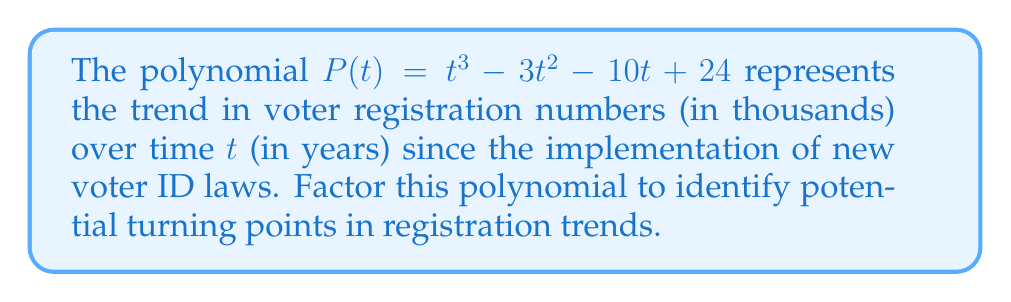Show me your answer to this math problem. To factor this polynomial, we'll follow these steps:

1) First, check if there are any rational roots using the rational root theorem. The possible rational roots are the factors of the constant term: ±1, ±2, ±3, ±4, ±6, ±8, ±12, ±24.

2) By testing these values, we find that t = 4 is a root. So (t - 4) is a factor.

3) Divide P(t) by (t - 4):

   $$(t^3 - 3t^2 - 10t + 24) ÷ (t - 4) = t^2 + t - 6$$

4) Now we need to factor the quadratic $t^2 + t - 6$. We can do this by finding two numbers that multiply to give -6 and add to give 1.

5) These numbers are 3 and -2. So we can factor $t^2 + t - 6$ as $(t + 3)(t - 2)$.

6) Combining all factors, we get:

   $$P(t) = (t - 4)(t + 3)(t - 2)$$

This factorization reveals that the polynomial has three roots: 4, -3, and 2, which represent potential turning points in the voter registration trend.
Answer: $(t - 4)(t + 3)(t - 2)$ 